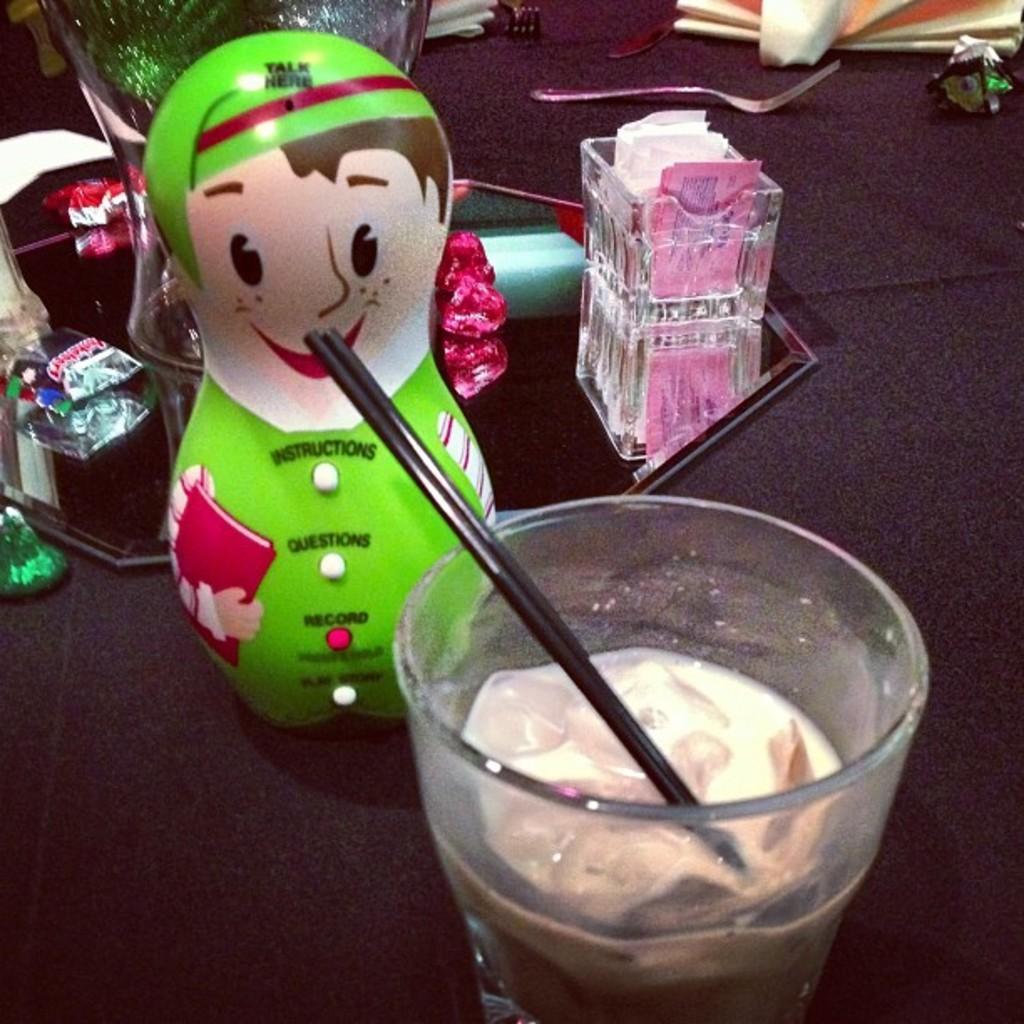Describe this image in one or two sentences. At the bottom of the image there is a table, on the table there is a glass and toys and there are some products and fork. 